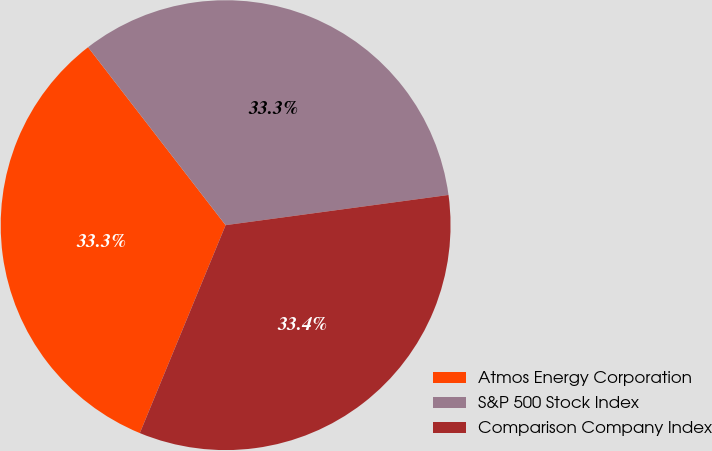Convert chart. <chart><loc_0><loc_0><loc_500><loc_500><pie_chart><fcel>Atmos Energy Corporation<fcel>S&P 500 Stock Index<fcel>Comparison Company Index<nl><fcel>33.3%<fcel>33.33%<fcel>33.37%<nl></chart> 